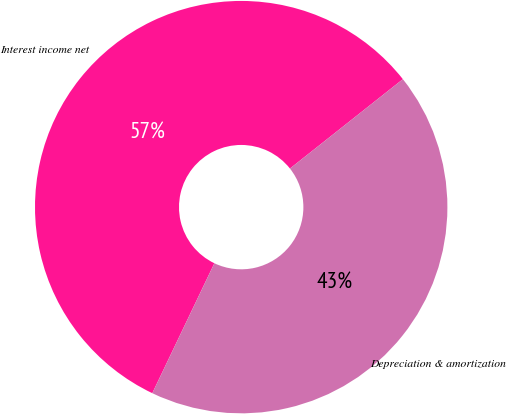Convert chart to OTSL. <chart><loc_0><loc_0><loc_500><loc_500><pie_chart><fcel>Interest income net<fcel>Depreciation & amortization<nl><fcel>57.25%<fcel>42.75%<nl></chart> 